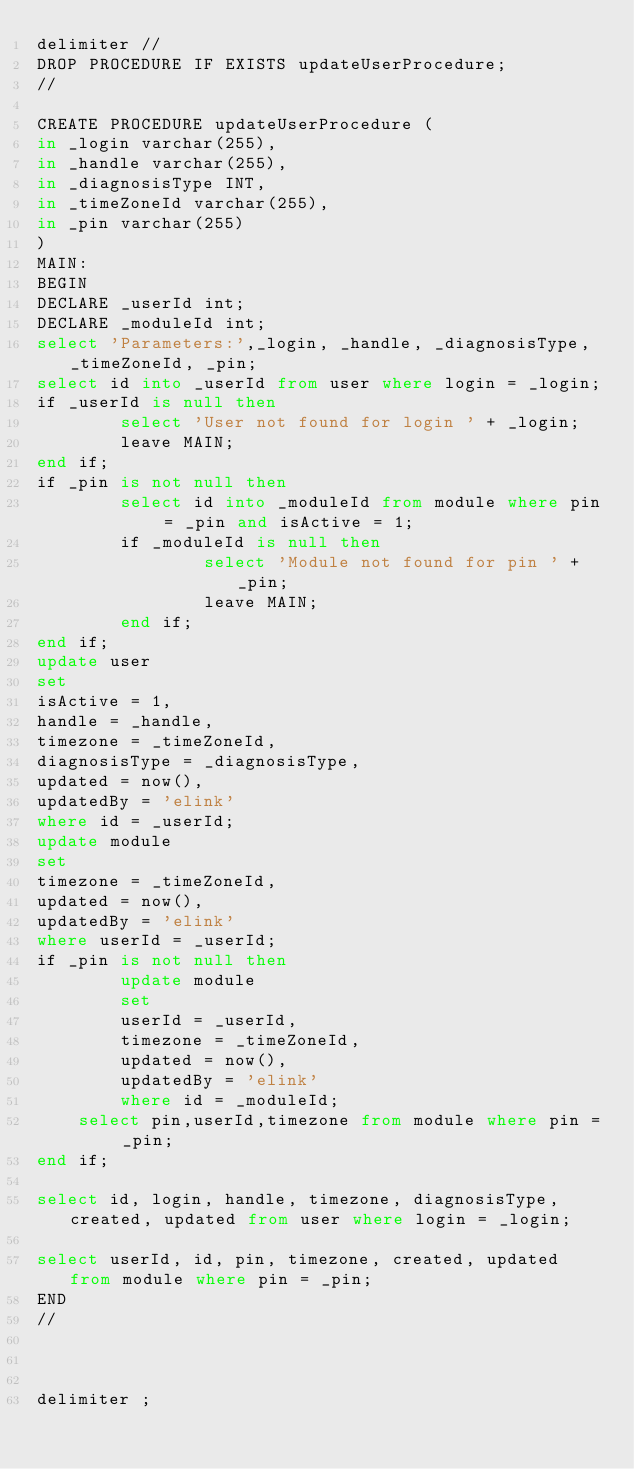<code> <loc_0><loc_0><loc_500><loc_500><_SQL_>delimiter //
DROP PROCEDURE IF EXISTS updateUserProcedure;
// 

CREATE PROCEDURE updateUserProcedure (
in _login varchar(255),
in _handle varchar(255),
in _diagnosisType INT,
in _timeZoneId varchar(255),
in _pin varchar(255)
)
MAIN:
BEGIN
DECLARE _userId int;
DECLARE _moduleId int;
select 'Parameters:',_login, _handle, _diagnosisType, _timeZoneId, _pin;
select id into _userId from user where login = _login;
if _userId is null then
        select 'User not found for login ' + _login;
        leave MAIN;
end if;
if _pin is not null then
        select id into _moduleId from module where pin = _pin and isActive = 1;
        if _moduleId is null then
                select 'Module not found for pin ' + _pin;
                leave MAIN;
        end if;
end if;
update user
set
isActive = 1,
handle = _handle,
timezone = _timeZoneId,
diagnosisType = _diagnosisType,
updated = now(),
updatedBy = 'elink'
where id = _userId;
update module
set
timezone = _timeZoneId,
updated = now(),
updatedBy = 'elink'
where userId = _userId;
if _pin is not null then
        update module
        set
        userId = _userId,
        timezone = _timeZoneId,
        updated = now(),
        updatedBy = 'elink'
        where id = _moduleId;
	select pin,userId,timezone from module where pin = _pin;
end if;

select id, login, handle, timezone, diagnosisType, created, updated from user where login = _login;

select userId, id, pin, timezone, created, updated from module where pin = _pin;
END
//



delimiter ;

</code> 